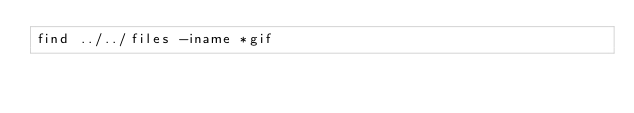Convert code to text. <code><loc_0><loc_0><loc_500><loc_500><_Bash_>find ../../files -iname *gif
</code> 